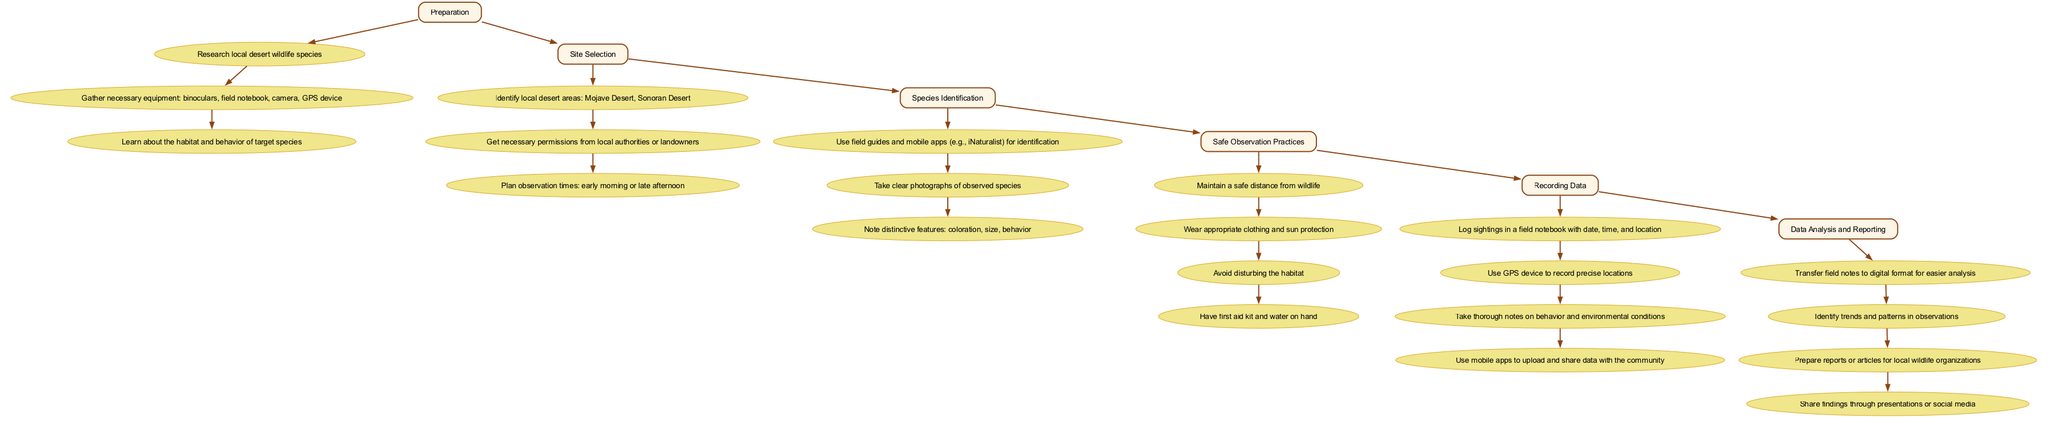What is the first step in monitoring local desert wildlife? According to the diagram, the first step listed under "Preparation" is to "Research local desert wildlife species."
Answer: Research local desert wildlife species How many items are listed under the "Safe Observation Practices" step? The diagram indicates that there are four items listed under "Safe Observation Practices," detailing necessary safety measures.
Answer: Four What is the relationship between "Species Identification" and "Recording Data"? The diagram shows that "Species Identification" is directly followed by "Recording Data," indicating that after identifying species, the next logical step is to record the data.
Answer: Directly follows Which step comes after "Site Selection"? The diagram specifies that after the "Site Selection" step, the next step is "Species Identification."
Answer: Species Identification What equipment is needed for monitoring? The first item under "Preparation" states, "Gather necessary equipment: binoculars, field notebook, camera, GPS device."
Answer: Binoculars, field notebook, camera, GPS device What is the main purpose of the "Data Analysis and Reporting" step? The diagram shows that the main purpose within "Data Analysis and Reporting" is to prepare reports or articles for local wildlife organizations based on the observations gathered in the earlier steps.
Answer: Prepare reports or articles In how many steps is the "Recording Data" mentioned in the flow chart? The "Recording Data" step is mentioned as a separate step itself and includes four specific items associated with logging and sharing data, thus represented as one distinct step.
Answer: One What must be done before identifying species? The diagram requires the completion of "Preparation" and "Site Selection" before moving on to "Species Identification." Thus, both need to be done first.
Answer: Preparation and Site Selection 